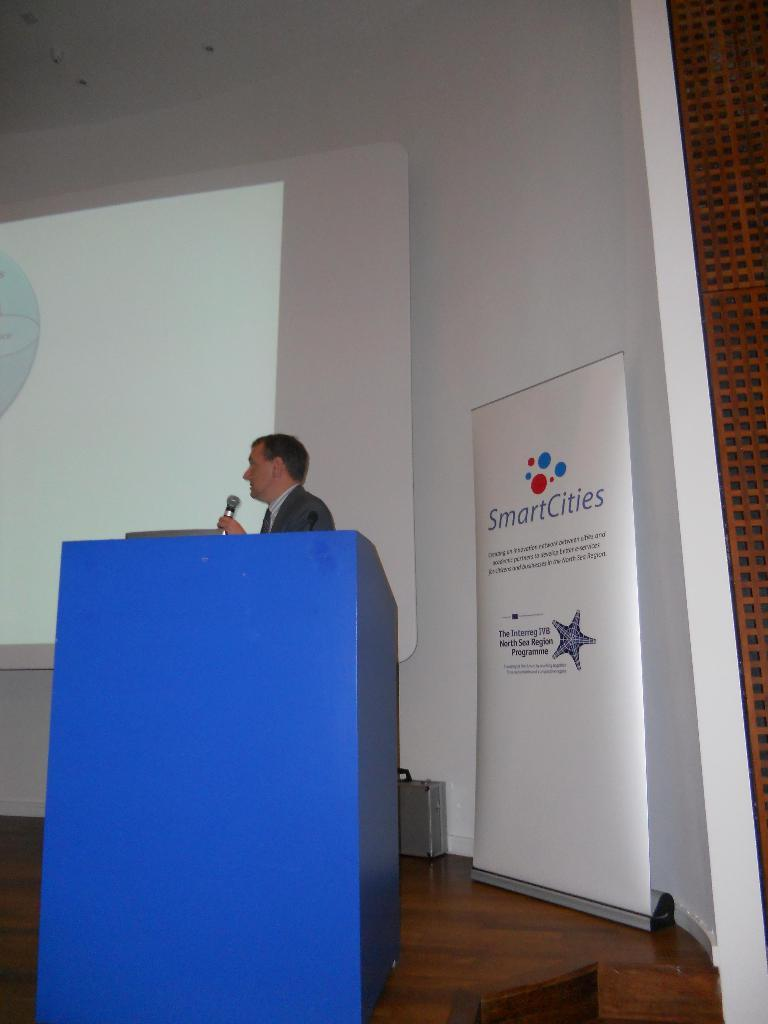What is the man in the image holding in his hand? The man is holding a mic in his hand. Where is the man standing in the image? The man is standing at a podium on the floor. What can be seen in the background of the image? There is a screen, a suitcase, a hoarding, and a wall in the background of the image. How many chairs are visible in the image? There are no chairs visible in the image. 